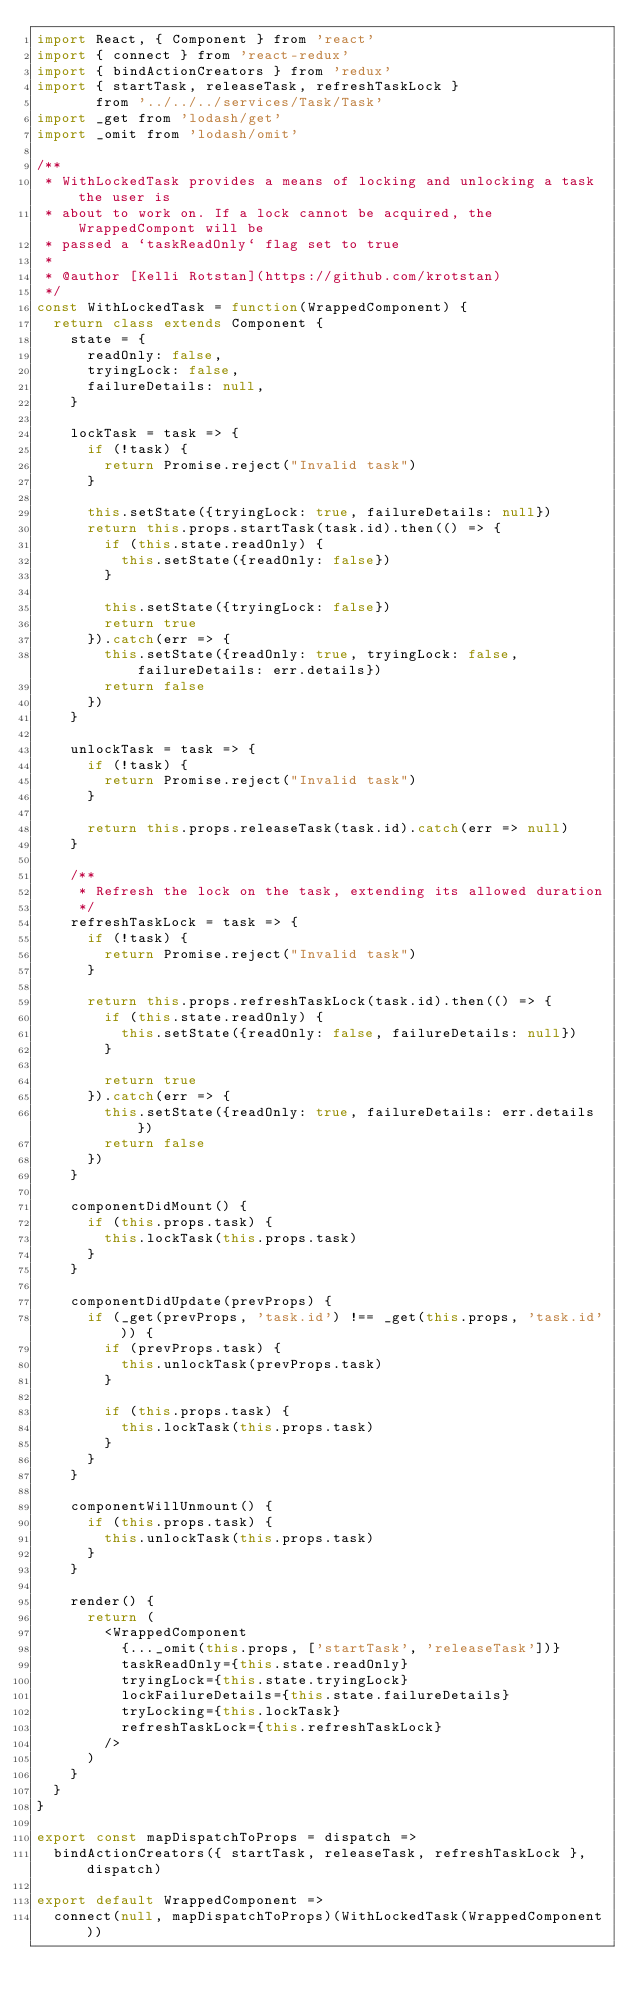Convert code to text. <code><loc_0><loc_0><loc_500><loc_500><_JavaScript_>import React, { Component } from 'react'
import { connect } from 'react-redux'
import { bindActionCreators } from 'redux'
import { startTask, releaseTask, refreshTaskLock }
       from '../../../services/Task/Task'
import _get from 'lodash/get'
import _omit from 'lodash/omit'

/**
 * WithLockedTask provides a means of locking and unlocking a task the user is
 * about to work on. If a lock cannot be acquired, the WrappedCompont will be
 * passed a `taskReadOnly` flag set to true
 *
 * @author [Kelli Rotstan](https://github.com/krotstan)
 */
const WithLockedTask = function(WrappedComponent) {
  return class extends Component {
    state = {
      readOnly: false,
      tryingLock: false,
      failureDetails: null,
    }

    lockTask = task => {
      if (!task) {
        return Promise.reject("Invalid task")
      }

      this.setState({tryingLock: true, failureDetails: null})
      return this.props.startTask(task.id).then(() => {
        if (this.state.readOnly) {
          this.setState({readOnly: false})
        }

        this.setState({tryingLock: false})
        return true
      }).catch(err => {
        this.setState({readOnly: true, tryingLock: false, failureDetails: err.details})
        return false
      })
    }

    unlockTask = task => {
      if (!task) {
        return Promise.reject("Invalid task")
      }

      return this.props.releaseTask(task.id).catch(err => null)
    }

    /**
     * Refresh the lock on the task, extending its allowed duration
     */
    refreshTaskLock = task => {
      if (!task) {
        return Promise.reject("Invalid task")
      }

      return this.props.refreshTaskLock(task.id).then(() => {
        if (this.state.readOnly) {
          this.setState({readOnly: false, failureDetails: null})
        }

        return true
      }).catch(err => {
        this.setState({readOnly: true, failureDetails: err.details})
        return false
      })
    }

    componentDidMount() {
      if (this.props.task) {
        this.lockTask(this.props.task)
      }
    }

    componentDidUpdate(prevProps) {
      if (_get(prevProps, 'task.id') !== _get(this.props, 'task.id')) {
        if (prevProps.task) {
          this.unlockTask(prevProps.task)
        }

        if (this.props.task) {
          this.lockTask(this.props.task)
        }
      }
    }

    componentWillUnmount() {
      if (this.props.task) {
        this.unlockTask(this.props.task)
      }
    }

    render() {
      return (
        <WrappedComponent
          {..._omit(this.props, ['startTask', 'releaseTask'])}
          taskReadOnly={this.state.readOnly}
          tryingLock={this.state.tryingLock}
          lockFailureDetails={this.state.failureDetails}
          tryLocking={this.lockTask}
          refreshTaskLock={this.refreshTaskLock}
        />
      )
    }
  }
}

export const mapDispatchToProps = dispatch =>
  bindActionCreators({ startTask, releaseTask, refreshTaskLock }, dispatch)

export default WrappedComponent =>
  connect(null, mapDispatchToProps)(WithLockedTask(WrappedComponent))
</code> 